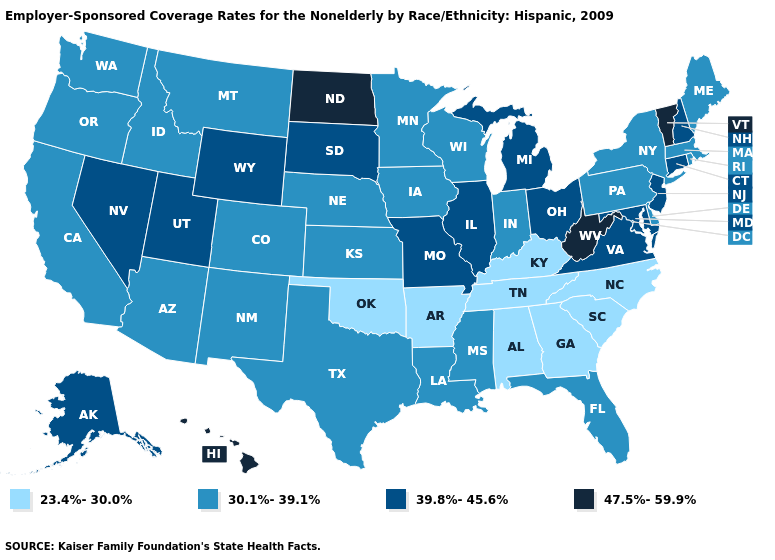Name the states that have a value in the range 39.8%-45.6%?
Give a very brief answer. Alaska, Connecticut, Illinois, Maryland, Michigan, Missouri, Nevada, New Hampshire, New Jersey, Ohio, South Dakota, Utah, Virginia, Wyoming. Name the states that have a value in the range 39.8%-45.6%?
Concise answer only. Alaska, Connecticut, Illinois, Maryland, Michigan, Missouri, Nevada, New Hampshire, New Jersey, Ohio, South Dakota, Utah, Virginia, Wyoming. Does South Carolina have a lower value than Virginia?
Short answer required. Yes. Does Illinois have the lowest value in the MidWest?
Give a very brief answer. No. Name the states that have a value in the range 30.1%-39.1%?
Give a very brief answer. Arizona, California, Colorado, Delaware, Florida, Idaho, Indiana, Iowa, Kansas, Louisiana, Maine, Massachusetts, Minnesota, Mississippi, Montana, Nebraska, New Mexico, New York, Oregon, Pennsylvania, Rhode Island, Texas, Washington, Wisconsin. Name the states that have a value in the range 30.1%-39.1%?
Answer briefly. Arizona, California, Colorado, Delaware, Florida, Idaho, Indiana, Iowa, Kansas, Louisiana, Maine, Massachusetts, Minnesota, Mississippi, Montana, Nebraska, New Mexico, New York, Oregon, Pennsylvania, Rhode Island, Texas, Washington, Wisconsin. Which states have the lowest value in the USA?
Short answer required. Alabama, Arkansas, Georgia, Kentucky, North Carolina, Oklahoma, South Carolina, Tennessee. Name the states that have a value in the range 23.4%-30.0%?
Give a very brief answer. Alabama, Arkansas, Georgia, Kentucky, North Carolina, Oklahoma, South Carolina, Tennessee. What is the value of Montana?
Short answer required. 30.1%-39.1%. What is the value of South Dakota?
Write a very short answer. 39.8%-45.6%. What is the value of Colorado?
Concise answer only. 30.1%-39.1%. What is the highest value in the USA?
Answer briefly. 47.5%-59.9%. Among the states that border Delaware , does Pennsylvania have the lowest value?
Quick response, please. Yes. What is the value of Wyoming?
Be succinct. 39.8%-45.6%. Does New Mexico have the same value as Kansas?
Be succinct. Yes. 